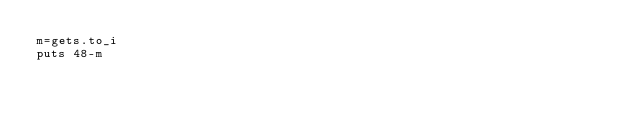Convert code to text. <code><loc_0><loc_0><loc_500><loc_500><_Ruby_>m=gets.to_i
puts 48-m</code> 